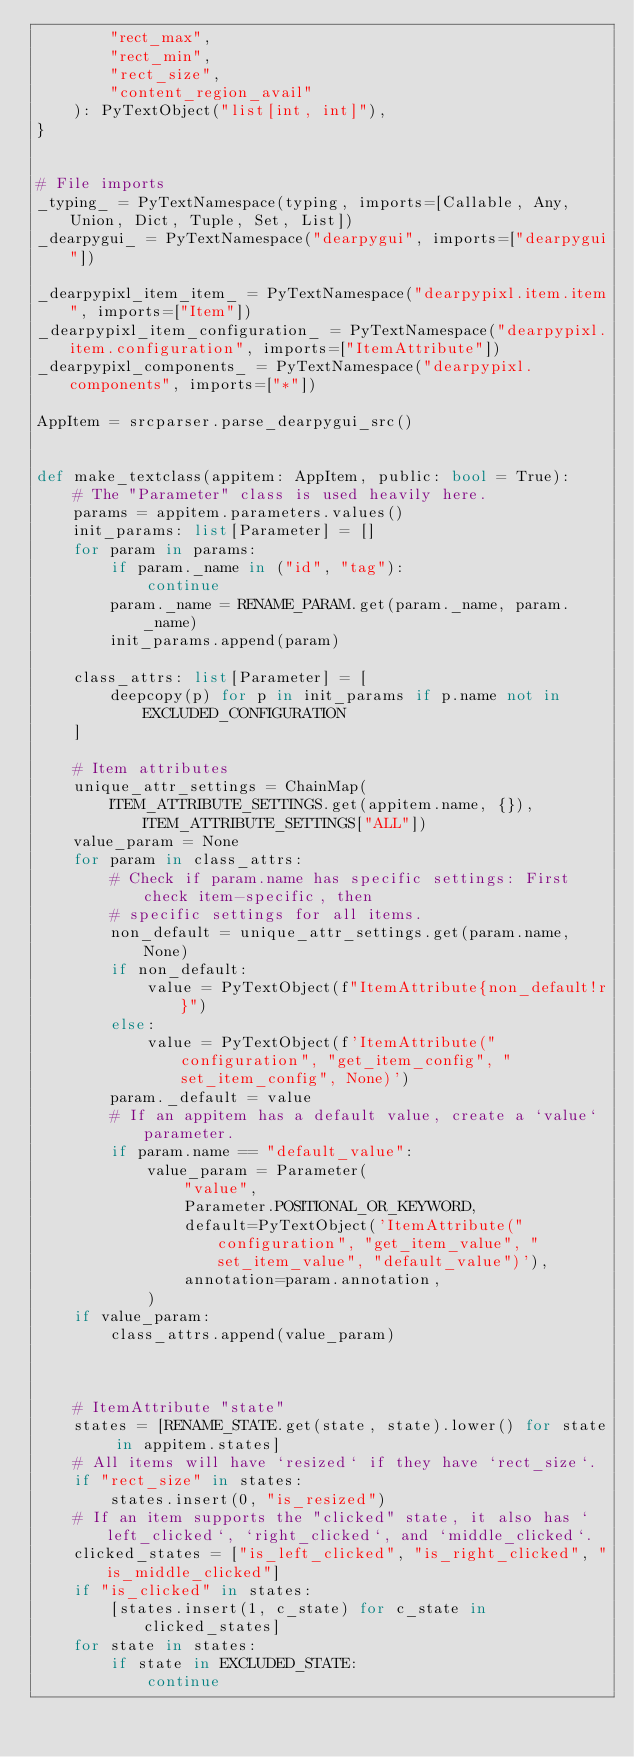Convert code to text. <code><loc_0><loc_0><loc_500><loc_500><_Python_>        "rect_max",
        "rect_min",
        "rect_size",
        "content_region_avail"
    ): PyTextObject("list[int, int]"),
}


# File imports
_typing_ = PyTextNamespace(typing, imports=[Callable, Any, Union, Dict, Tuple, Set, List])
_dearpygui_ = PyTextNamespace("dearpygui", imports=["dearpygui"])

_dearpypixl_item_item_ = PyTextNamespace("dearpypixl.item.item", imports=["Item"])
_dearpypixl_item_configuration_ = PyTextNamespace("dearpypixl.item.configuration", imports=["ItemAttribute"])
_dearpypixl_components_ = PyTextNamespace("dearpypixl.components", imports=["*"])

AppItem = srcparser.parse_dearpygui_src()


def make_textclass(appitem: AppItem, public: bool = True):
    # The "Parameter" class is used heavily here.
    params = appitem.parameters.values()
    init_params: list[Parameter] = []
    for param in params:
        if param._name in ("id", "tag"):
            continue
        param._name = RENAME_PARAM.get(param._name, param._name)
        init_params.append(param)

    class_attrs: list[Parameter] = [
        deepcopy(p) for p in init_params if p.name not in EXCLUDED_CONFIGURATION
    ]

    # Item attributes
    unique_attr_settings = ChainMap(
        ITEM_ATTRIBUTE_SETTINGS.get(appitem.name, {}), ITEM_ATTRIBUTE_SETTINGS["ALL"])
    value_param = None
    for param in class_attrs:
        # Check if param.name has specific settings: First check item-specific, then
        # specific settings for all items.
        non_default = unique_attr_settings.get(param.name, None)
        if non_default:
            value = PyTextObject(f"ItemAttribute{non_default!r}")
        else:
            value = PyTextObject(f'ItemAttribute("configuration", "get_item_config", "set_item_config", None)')
        param._default = value
        # If an appitem has a default value, create a `value` parameter.
        if param.name == "default_value":
            value_param = Parameter(
                "value",
                Parameter.POSITIONAL_OR_KEYWORD,
                default=PyTextObject('ItemAttribute("configuration", "get_item_value", "set_item_value", "default_value")'),
                annotation=param.annotation,
            )
    if value_param:
        class_attrs.append(value_param)



    # ItemAttribute "state"
    states = [RENAME_STATE.get(state, state).lower() for state in appitem.states]
    # All items will have `resized` if they have `rect_size`.
    if "rect_size" in states:
        states.insert(0, "is_resized")
    # If an item supports the "clicked" state, it also has `left_clicked`, `right_clicked`, and `middle_clicked`.
    clicked_states = ["is_left_clicked", "is_right_clicked", "is_middle_clicked"]
    if "is_clicked" in states:
        [states.insert(1, c_state) for c_state in clicked_states]
    for state in states:
        if state in EXCLUDED_STATE:
            continue</code> 